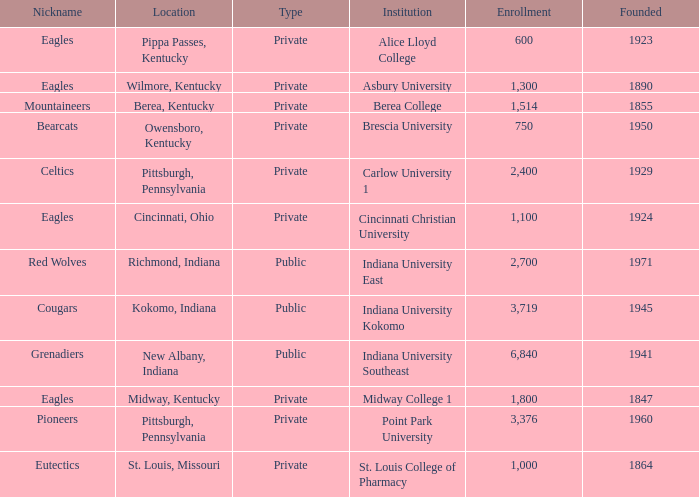Which of the private colleges is the oldest, and whose nickname is the Mountaineers? 1855.0. 